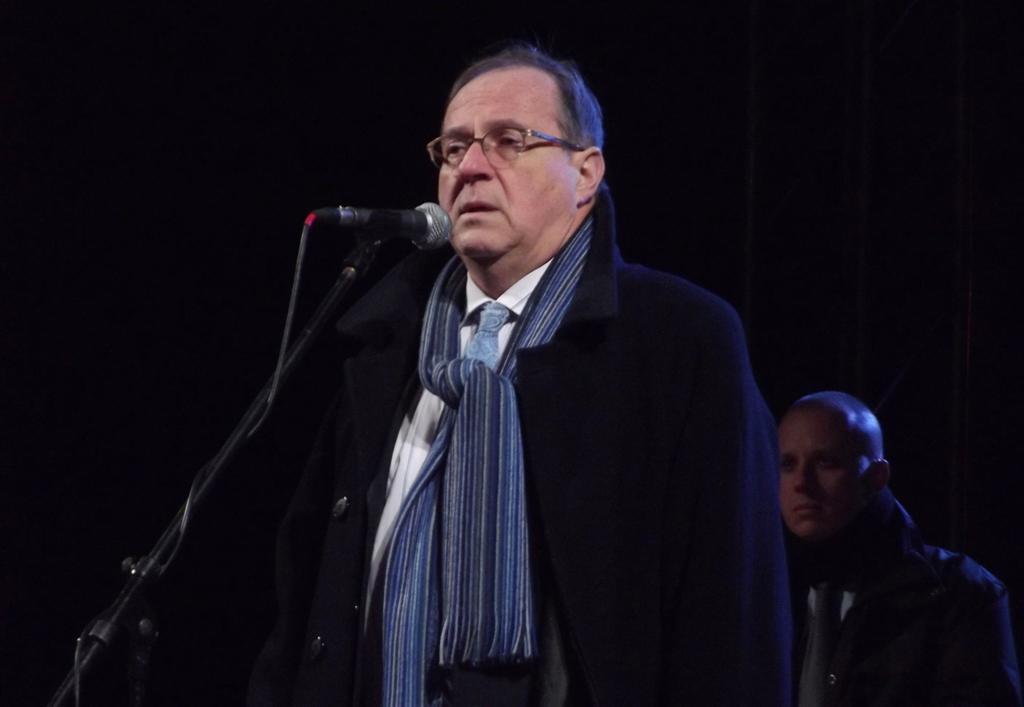Could you give a brief overview of what you see in this image? In this image, I see a man who is wearing a suit and standing in front of a mic. In the background I can see another man. 